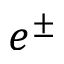<formula> <loc_0><loc_0><loc_500><loc_500>e ^ { \pm }</formula> 